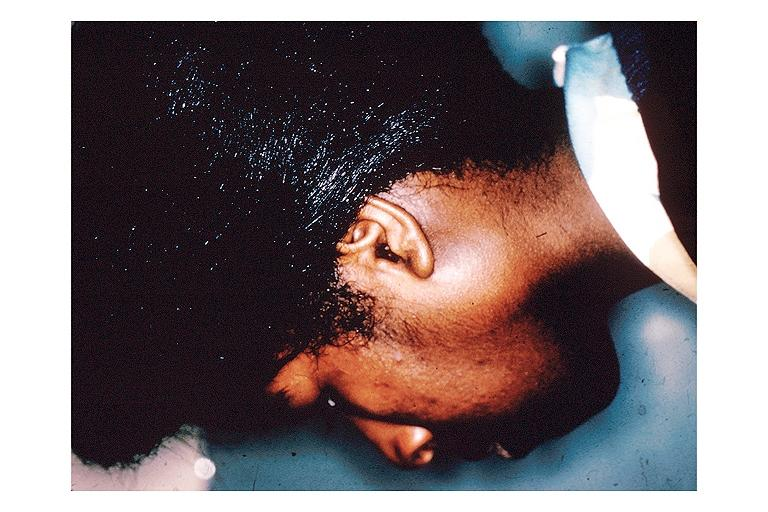s oral present?
Answer the question using a single word or phrase. Yes 